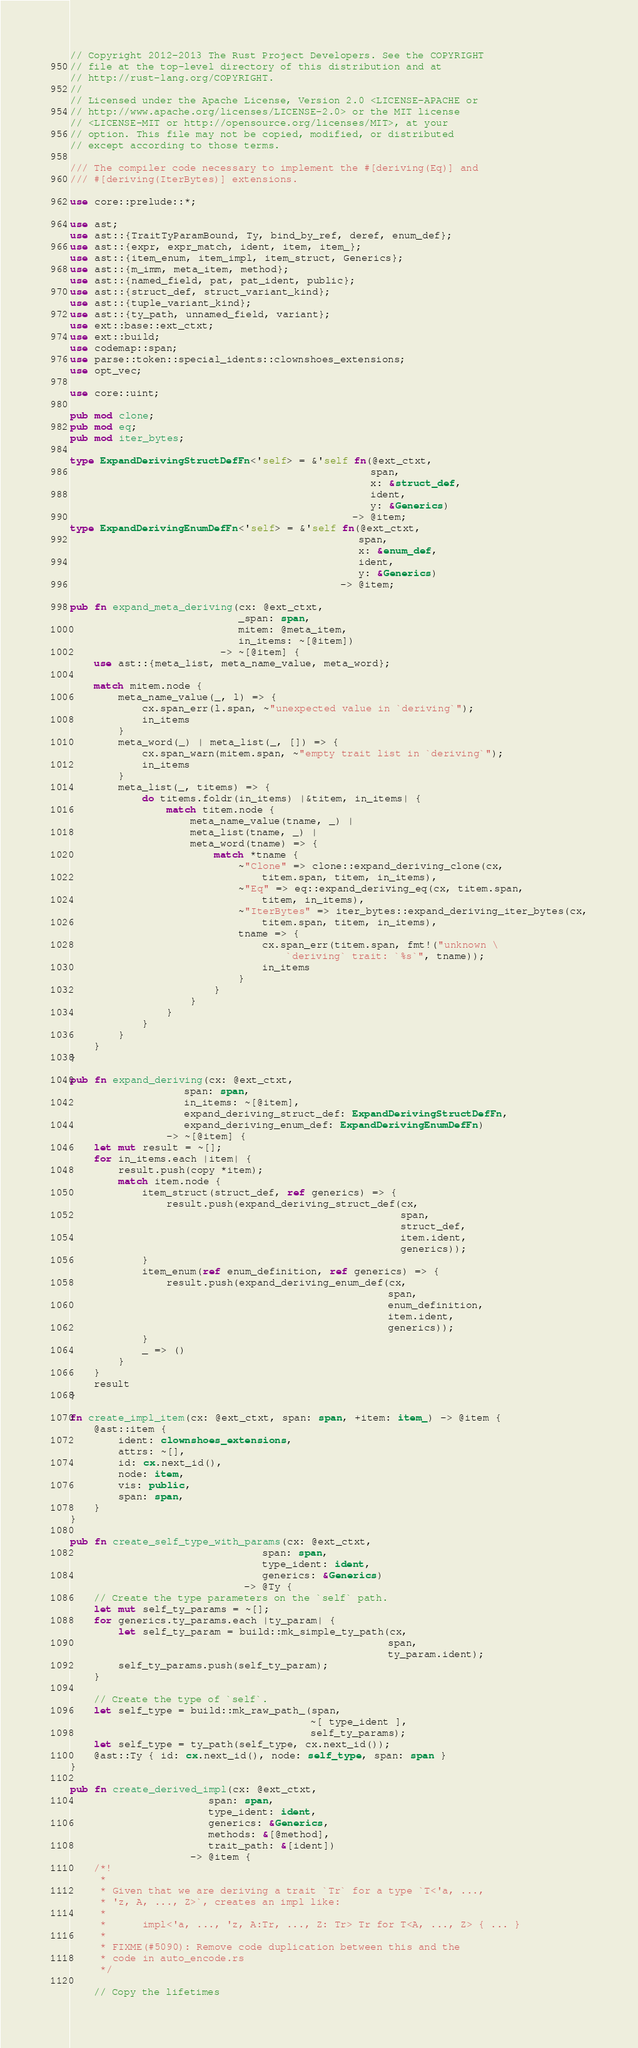Convert code to text. <code><loc_0><loc_0><loc_500><loc_500><_Rust_>// Copyright 2012-2013 The Rust Project Developers. See the COPYRIGHT
// file at the top-level directory of this distribution and at
// http://rust-lang.org/COPYRIGHT.
//
// Licensed under the Apache License, Version 2.0 <LICENSE-APACHE or
// http://www.apache.org/licenses/LICENSE-2.0> or the MIT license
// <LICENSE-MIT or http://opensource.org/licenses/MIT>, at your
// option. This file may not be copied, modified, or distributed
// except according to those terms.

/// The compiler code necessary to implement the #[deriving(Eq)] and
/// #[deriving(IterBytes)] extensions.

use core::prelude::*;

use ast;
use ast::{TraitTyParamBound, Ty, bind_by_ref, deref, enum_def};
use ast::{expr, expr_match, ident, item, item_};
use ast::{item_enum, item_impl, item_struct, Generics};
use ast::{m_imm, meta_item, method};
use ast::{named_field, pat, pat_ident, public};
use ast::{struct_def, struct_variant_kind};
use ast::{tuple_variant_kind};
use ast::{ty_path, unnamed_field, variant};
use ext::base::ext_ctxt;
use ext::build;
use codemap::span;
use parse::token::special_idents::clownshoes_extensions;
use opt_vec;

use core::uint;

pub mod clone;
pub mod eq;
pub mod iter_bytes;

type ExpandDerivingStructDefFn<'self> = &'self fn(@ext_ctxt,
                                                  span,
                                                  x: &struct_def,
                                                  ident,
                                                  y: &Generics)
                                               -> @item;
type ExpandDerivingEnumDefFn<'self> = &'self fn(@ext_ctxt,
                                                span,
                                                x: &enum_def,
                                                ident,
                                                y: &Generics)
                                             -> @item;

pub fn expand_meta_deriving(cx: @ext_ctxt,
                            _span: span,
                            mitem: @meta_item,
                            in_items: ~[@item])
                         -> ~[@item] {
    use ast::{meta_list, meta_name_value, meta_word};

    match mitem.node {
        meta_name_value(_, l) => {
            cx.span_err(l.span, ~"unexpected value in `deriving`");
            in_items
        }
        meta_word(_) | meta_list(_, []) => {
            cx.span_warn(mitem.span, ~"empty trait list in `deriving`");
            in_items
        }
        meta_list(_, titems) => {
            do titems.foldr(in_items) |&titem, in_items| {
                match titem.node {
                    meta_name_value(tname, _) |
                    meta_list(tname, _) |
                    meta_word(tname) => {
                        match *tname {
                            ~"Clone" => clone::expand_deriving_clone(cx,
                                titem.span, titem, in_items),
                            ~"Eq" => eq::expand_deriving_eq(cx, titem.span,
                                titem, in_items),
                            ~"IterBytes" => iter_bytes::expand_deriving_iter_bytes(cx,
                                titem.span, titem, in_items),
                            tname => {
                                cx.span_err(titem.span, fmt!("unknown \
                                    `deriving` trait: `%s`", tname));
                                in_items
                            }
                        }
                    }
                }
            }
        }
    }
}

pub fn expand_deriving(cx: @ext_ctxt,
                   span: span,
                   in_items: ~[@item],
                   expand_deriving_struct_def: ExpandDerivingStructDefFn,
                   expand_deriving_enum_def: ExpandDerivingEnumDefFn)
                -> ~[@item] {
    let mut result = ~[];
    for in_items.each |item| {
        result.push(copy *item);
        match item.node {
            item_struct(struct_def, ref generics) => {
                result.push(expand_deriving_struct_def(cx,
                                                       span,
                                                       struct_def,
                                                       item.ident,
                                                       generics));
            }
            item_enum(ref enum_definition, ref generics) => {
                result.push(expand_deriving_enum_def(cx,
                                                     span,
                                                     enum_definition,
                                                     item.ident,
                                                     generics));
            }
            _ => ()
        }
    }
    result
}

fn create_impl_item(cx: @ext_ctxt, span: span, +item: item_) -> @item {
    @ast::item {
        ident: clownshoes_extensions,
        attrs: ~[],
        id: cx.next_id(),
        node: item,
        vis: public,
        span: span,
    }
}

pub fn create_self_type_with_params(cx: @ext_ctxt,
                                span: span,
                                type_ident: ident,
                                generics: &Generics)
                             -> @Ty {
    // Create the type parameters on the `self` path.
    let mut self_ty_params = ~[];
    for generics.ty_params.each |ty_param| {
        let self_ty_param = build::mk_simple_ty_path(cx,
                                                     span,
                                                     ty_param.ident);
        self_ty_params.push(self_ty_param);
    }

    // Create the type of `self`.
    let self_type = build::mk_raw_path_(span,
                                        ~[ type_ident ],
                                        self_ty_params);
    let self_type = ty_path(self_type, cx.next_id());
    @ast::Ty { id: cx.next_id(), node: self_type, span: span }
}

pub fn create_derived_impl(cx: @ext_ctxt,
                       span: span,
                       type_ident: ident,
                       generics: &Generics,
                       methods: &[@method],
                       trait_path: &[ident])
                    -> @item {
    /*!
     *
     * Given that we are deriving a trait `Tr` for a type `T<'a, ...,
     * 'z, A, ..., Z>`, creates an impl like:
     *
     *      impl<'a, ..., 'z, A:Tr, ..., Z: Tr> Tr for T<A, ..., Z> { ... }
     *
     * FIXME(#5090): Remove code duplication between this and the
     * code in auto_encode.rs
     */

    // Copy the lifetimes</code> 